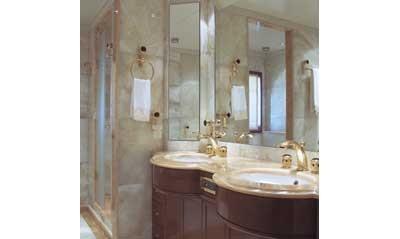What color is the faucet?
Give a very brief answer. Gold. What room is this?
Be succinct. Bathroom. What color are the counters?
Short answer required. Tan. Is there a tub?
Short answer required. No. 